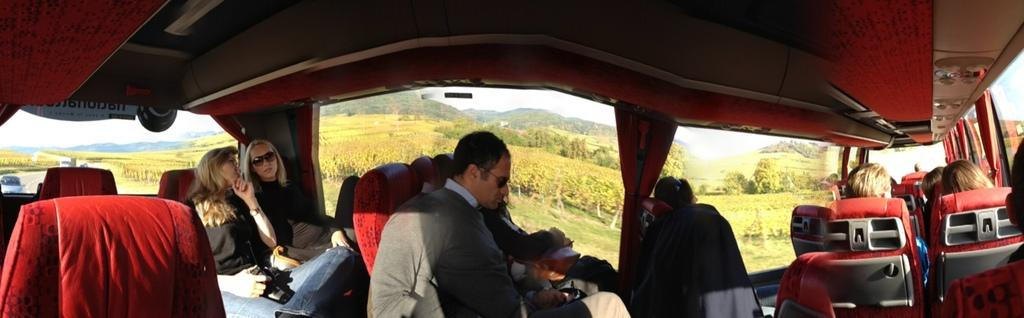What is the main subject of the image? The main subject of the image is a vehicle. Who or what is inside the vehicle? There are people sitting in the vehicle. Can you describe the people in the vehicle? There are men and women among the people in the vehicle. What can be seen in the background of the image? There are trees, hills, and the sky visible in the background of the image. What type of letters can be seen hanging on the church in the image? There is no church present in the image, so there are no letters hanging on a church. 